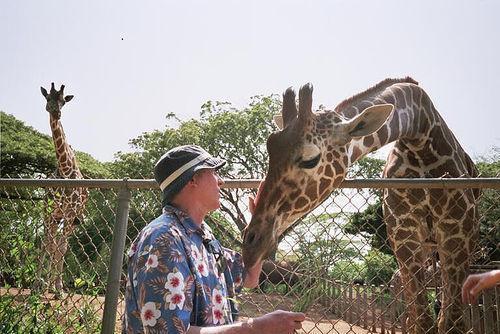How many giraffes are interacting with the man?
Pick the right solution, then justify: 'Answer: answer
Rationale: rationale.'
Options: Two, three, four, one. Answer: one.
Rationale: There is only one giraffe. 